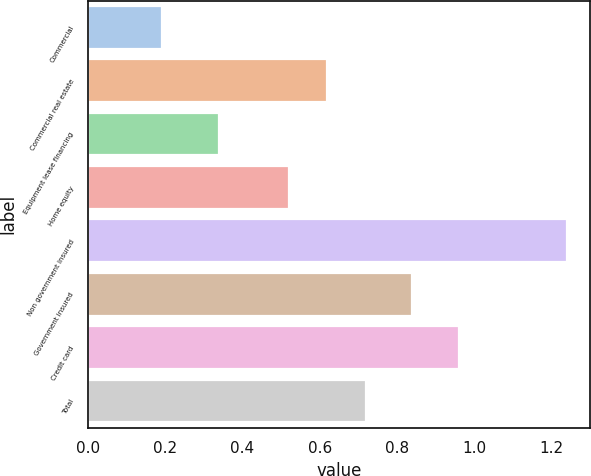Convert chart. <chart><loc_0><loc_0><loc_500><loc_500><bar_chart><fcel>Commercial<fcel>Commercial real estate<fcel>Equipment lease financing<fcel>Home equity<fcel>Non government insured<fcel>Government insured<fcel>Credit card<fcel>Total<nl><fcel>0.19<fcel>0.62<fcel>0.34<fcel>0.52<fcel>1.24<fcel>0.84<fcel>0.96<fcel>0.72<nl></chart> 